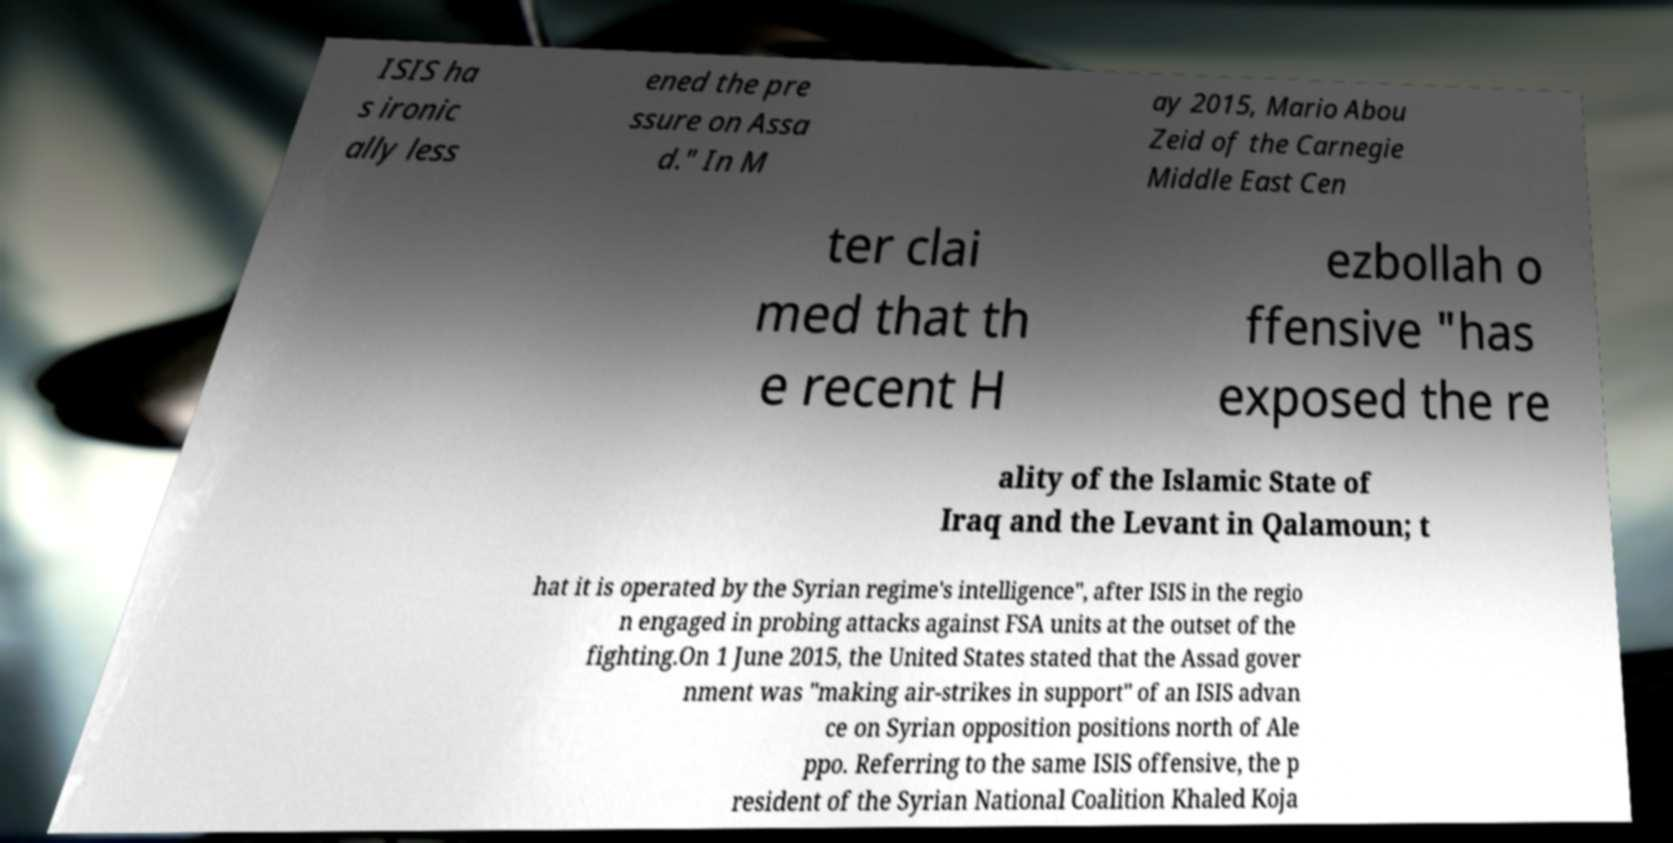I need the written content from this picture converted into text. Can you do that? ISIS ha s ironic ally less ened the pre ssure on Assa d." In M ay 2015, Mario Abou Zeid of the Carnegie Middle East Cen ter clai med that th e recent H ezbollah o ffensive "has exposed the re ality of the Islamic State of Iraq and the Levant in Qalamoun; t hat it is operated by the Syrian regime's intelligence", after ISIS in the regio n engaged in probing attacks against FSA units at the outset of the fighting.On 1 June 2015, the United States stated that the Assad gover nment was "making air-strikes in support" of an ISIS advan ce on Syrian opposition positions north of Ale ppo. Referring to the same ISIS offensive, the p resident of the Syrian National Coalition Khaled Koja 